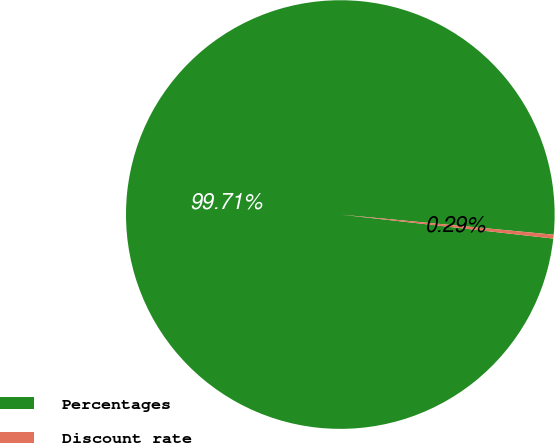Convert chart. <chart><loc_0><loc_0><loc_500><loc_500><pie_chart><fcel>Percentages<fcel>Discount rate<nl><fcel>99.71%<fcel>0.29%<nl></chart> 